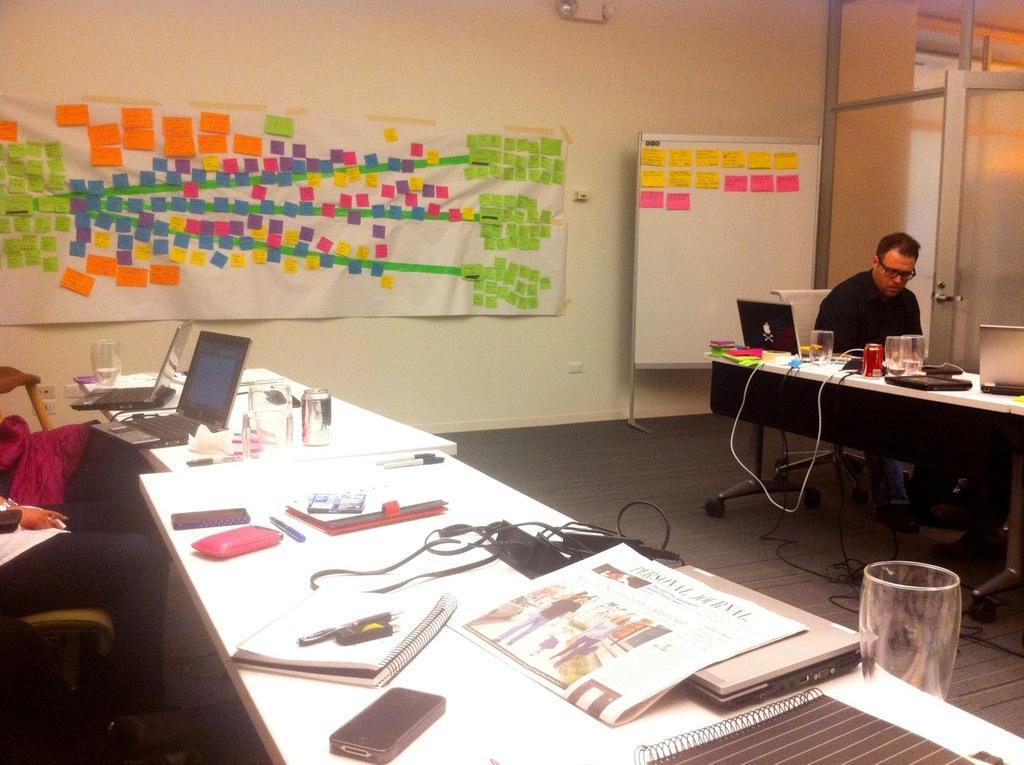Can you describe this image briefly? This is a picture consist of a inside of a room and left side there is a table,and there are the two persons sitting on the chair on the left side ,and there is a glass, laptop,pen,cable cards visible. And corner i can see a table ,on the table there are the some objects kept on that. In front of a table a person wearing a black color shirt ,she is sit on the chair ,on the middle i can see a board and there are some colorful papers attached to the wall. 